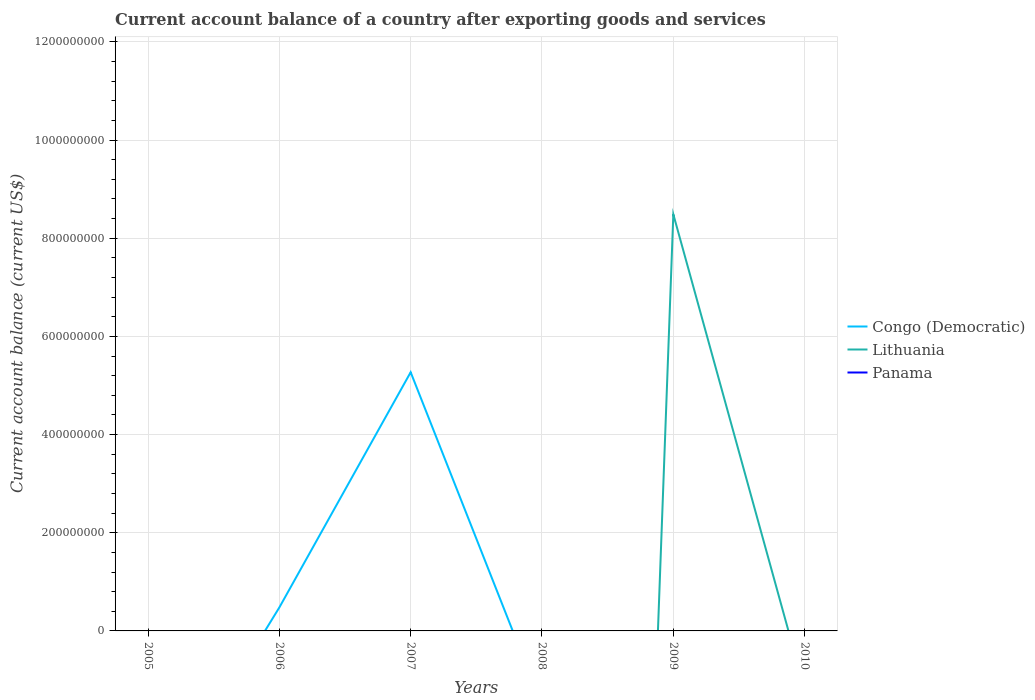How many different coloured lines are there?
Offer a very short reply. 2. What is the difference between the highest and the second highest account balance in Congo (Democratic)?
Make the answer very short. 5.27e+08. What is the difference between the highest and the lowest account balance in Lithuania?
Your response must be concise. 1. How many years are there in the graph?
Your answer should be very brief. 6. Are the values on the major ticks of Y-axis written in scientific E-notation?
Your answer should be compact. No. Where does the legend appear in the graph?
Provide a short and direct response. Center right. What is the title of the graph?
Offer a very short reply. Current account balance of a country after exporting goods and services. What is the label or title of the X-axis?
Your answer should be compact. Years. What is the label or title of the Y-axis?
Give a very brief answer. Current account balance (current US$). What is the Current account balance (current US$) of Congo (Democratic) in 2005?
Ensure brevity in your answer.  0. What is the Current account balance (current US$) in Panama in 2005?
Your answer should be compact. 0. What is the Current account balance (current US$) in Congo (Democratic) in 2006?
Provide a short and direct response. 4.78e+07. What is the Current account balance (current US$) of Congo (Democratic) in 2007?
Provide a succinct answer. 5.27e+08. What is the Current account balance (current US$) of Lithuania in 2007?
Keep it short and to the point. 0. What is the Current account balance (current US$) in Panama in 2007?
Provide a succinct answer. 0. What is the Current account balance (current US$) of Congo (Democratic) in 2008?
Your response must be concise. 0. What is the Current account balance (current US$) in Panama in 2008?
Give a very brief answer. 0. What is the Current account balance (current US$) in Lithuania in 2009?
Provide a short and direct response. 8.49e+08. What is the Current account balance (current US$) in Panama in 2009?
Offer a very short reply. 0. What is the Current account balance (current US$) of Congo (Democratic) in 2010?
Ensure brevity in your answer.  0. What is the Current account balance (current US$) of Panama in 2010?
Provide a succinct answer. 0. Across all years, what is the maximum Current account balance (current US$) of Congo (Democratic)?
Your response must be concise. 5.27e+08. Across all years, what is the maximum Current account balance (current US$) in Lithuania?
Give a very brief answer. 8.49e+08. Across all years, what is the minimum Current account balance (current US$) of Congo (Democratic)?
Make the answer very short. 0. Across all years, what is the minimum Current account balance (current US$) in Lithuania?
Offer a very short reply. 0. What is the total Current account balance (current US$) of Congo (Democratic) in the graph?
Provide a short and direct response. 5.75e+08. What is the total Current account balance (current US$) in Lithuania in the graph?
Provide a succinct answer. 8.49e+08. What is the difference between the Current account balance (current US$) of Congo (Democratic) in 2006 and that in 2007?
Ensure brevity in your answer.  -4.79e+08. What is the difference between the Current account balance (current US$) of Congo (Democratic) in 2006 and the Current account balance (current US$) of Lithuania in 2009?
Keep it short and to the point. -8.01e+08. What is the difference between the Current account balance (current US$) in Congo (Democratic) in 2007 and the Current account balance (current US$) in Lithuania in 2009?
Give a very brief answer. -3.22e+08. What is the average Current account balance (current US$) of Congo (Democratic) per year?
Keep it short and to the point. 9.58e+07. What is the average Current account balance (current US$) of Lithuania per year?
Keep it short and to the point. 1.41e+08. What is the ratio of the Current account balance (current US$) in Congo (Democratic) in 2006 to that in 2007?
Provide a succinct answer. 0.09. What is the difference between the highest and the lowest Current account balance (current US$) in Congo (Democratic)?
Your response must be concise. 5.27e+08. What is the difference between the highest and the lowest Current account balance (current US$) of Lithuania?
Make the answer very short. 8.49e+08. 